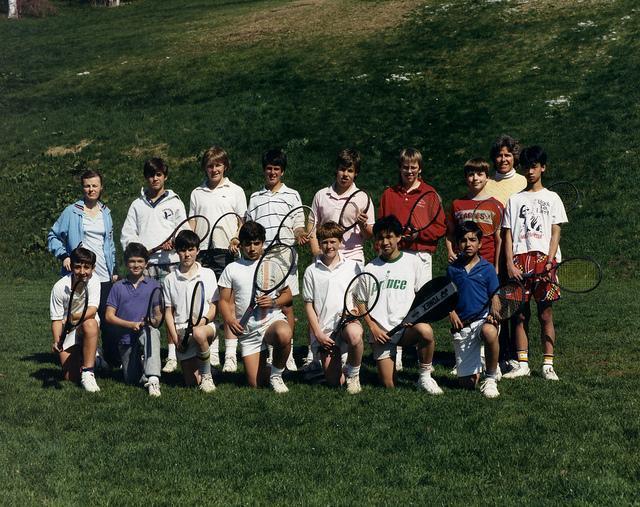How many people are sitting down?
Give a very brief answer. 0. How many people can be seen?
Give a very brief answer. 13. 